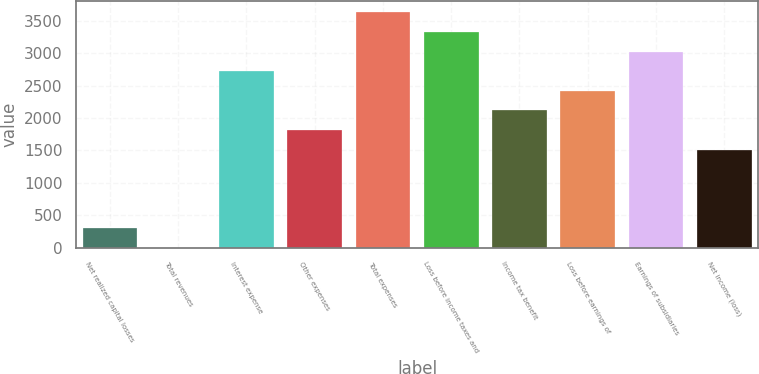<chart> <loc_0><loc_0><loc_500><loc_500><bar_chart><fcel>Net realized capital losses<fcel>Total revenues<fcel>Interest expense<fcel>Other expenses<fcel>Total expenses<fcel>Loss before income taxes and<fcel>Income tax benefit<fcel>Loss before earnings of<fcel>Earnings of subsidiaries<fcel>Net income (loss)<nl><fcel>305.2<fcel>3<fcel>2722.8<fcel>1816.2<fcel>3629.4<fcel>3327.2<fcel>2118.4<fcel>2420.6<fcel>3025<fcel>1514<nl></chart> 